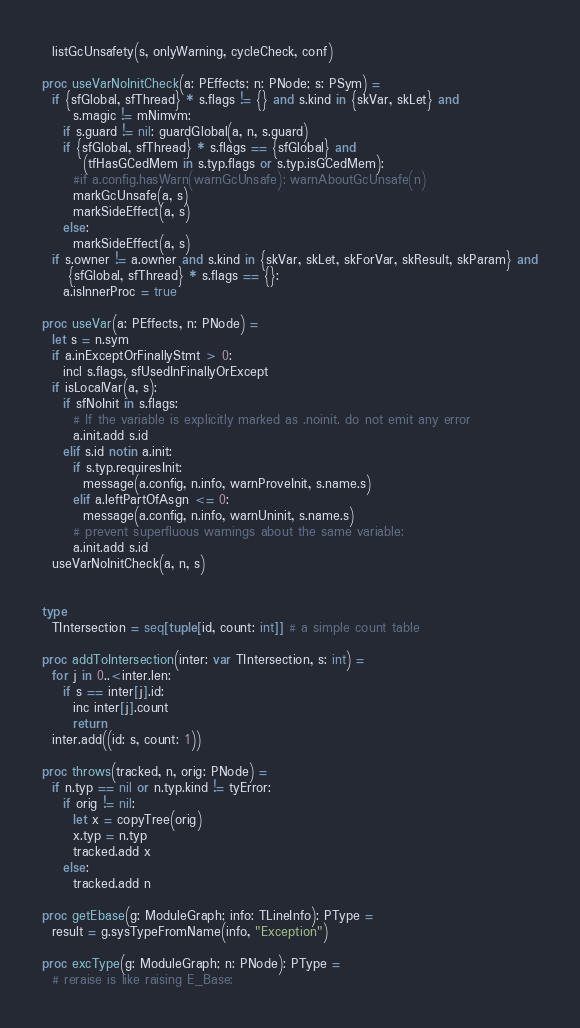<code> <loc_0><loc_0><loc_500><loc_500><_Nim_>  listGcUnsafety(s, onlyWarning, cycleCheck, conf)

proc useVarNoInitCheck(a: PEffects; n: PNode; s: PSym) =
  if {sfGlobal, sfThread} * s.flags != {} and s.kind in {skVar, skLet} and
      s.magic != mNimvm:
    if s.guard != nil: guardGlobal(a, n, s.guard)
    if {sfGlobal, sfThread} * s.flags == {sfGlobal} and
        (tfHasGCedMem in s.typ.flags or s.typ.isGCedMem):
      #if a.config.hasWarn(warnGcUnsafe): warnAboutGcUnsafe(n)
      markGcUnsafe(a, s)
      markSideEffect(a, s)
    else:
      markSideEffect(a, s)
  if s.owner != a.owner and s.kind in {skVar, skLet, skForVar, skResult, skParam} and
     {sfGlobal, sfThread} * s.flags == {}:
    a.isInnerProc = true

proc useVar(a: PEffects, n: PNode) =
  let s = n.sym
  if a.inExceptOrFinallyStmt > 0:
    incl s.flags, sfUsedInFinallyOrExcept
  if isLocalVar(a, s):
    if sfNoInit in s.flags:
      # If the variable is explicitly marked as .noinit. do not emit any error
      a.init.add s.id
    elif s.id notin a.init:
      if s.typ.requiresInit:
        message(a.config, n.info, warnProveInit, s.name.s)
      elif a.leftPartOfAsgn <= 0:
        message(a.config, n.info, warnUninit, s.name.s)
      # prevent superfluous warnings about the same variable:
      a.init.add s.id
  useVarNoInitCheck(a, n, s)


type
  TIntersection = seq[tuple[id, count: int]] # a simple count table

proc addToIntersection(inter: var TIntersection, s: int) =
  for j in 0..<inter.len:
    if s == inter[j].id:
      inc inter[j].count
      return
  inter.add((id: s, count: 1))

proc throws(tracked, n, orig: PNode) =
  if n.typ == nil or n.typ.kind != tyError:
    if orig != nil:
      let x = copyTree(orig)
      x.typ = n.typ
      tracked.add x
    else:
      tracked.add n

proc getEbase(g: ModuleGraph; info: TLineInfo): PType =
  result = g.sysTypeFromName(info, "Exception")

proc excType(g: ModuleGraph; n: PNode): PType =
  # reraise is like raising E_Base:</code> 